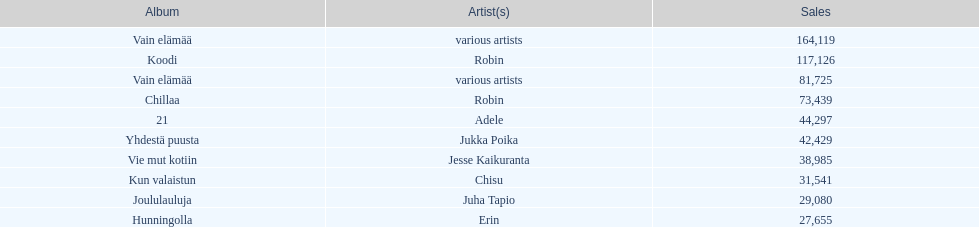Which album had the least amount of sales? Hunningolla. 